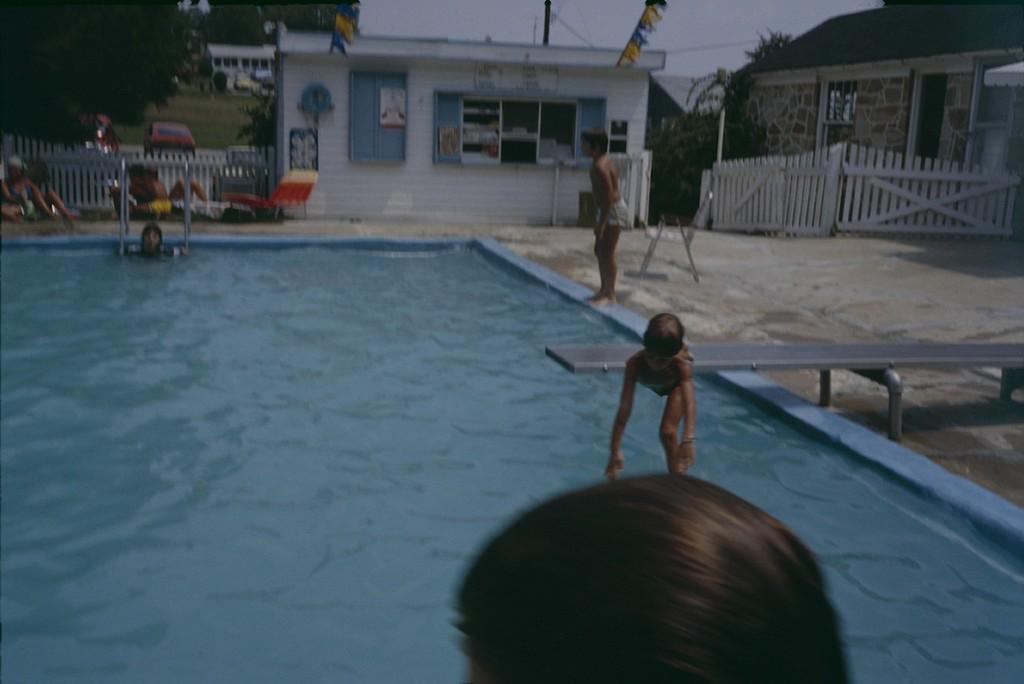Could you give a brief overview of what you see in this image? This is a swimming pool with the water. I can see a group of people sitting. Here is a boy standing. This looks like a room with a window. I can see a fence. This is a wooden gate. I can see another boy jumping. This looks like a house. These are the trees. I can see a vehicle. 